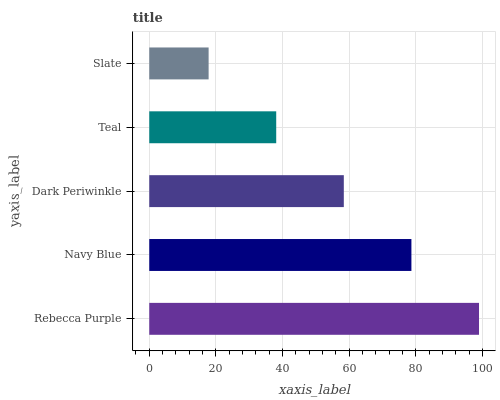Is Slate the minimum?
Answer yes or no. Yes. Is Rebecca Purple the maximum?
Answer yes or no. Yes. Is Navy Blue the minimum?
Answer yes or no. No. Is Navy Blue the maximum?
Answer yes or no. No. Is Rebecca Purple greater than Navy Blue?
Answer yes or no. Yes. Is Navy Blue less than Rebecca Purple?
Answer yes or no. Yes. Is Navy Blue greater than Rebecca Purple?
Answer yes or no. No. Is Rebecca Purple less than Navy Blue?
Answer yes or no. No. Is Dark Periwinkle the high median?
Answer yes or no. Yes. Is Dark Periwinkle the low median?
Answer yes or no. Yes. Is Navy Blue the high median?
Answer yes or no. No. Is Teal the low median?
Answer yes or no. No. 